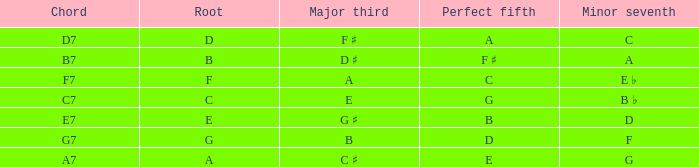What is the Chord with a Minor that is seventh of f? G7. 